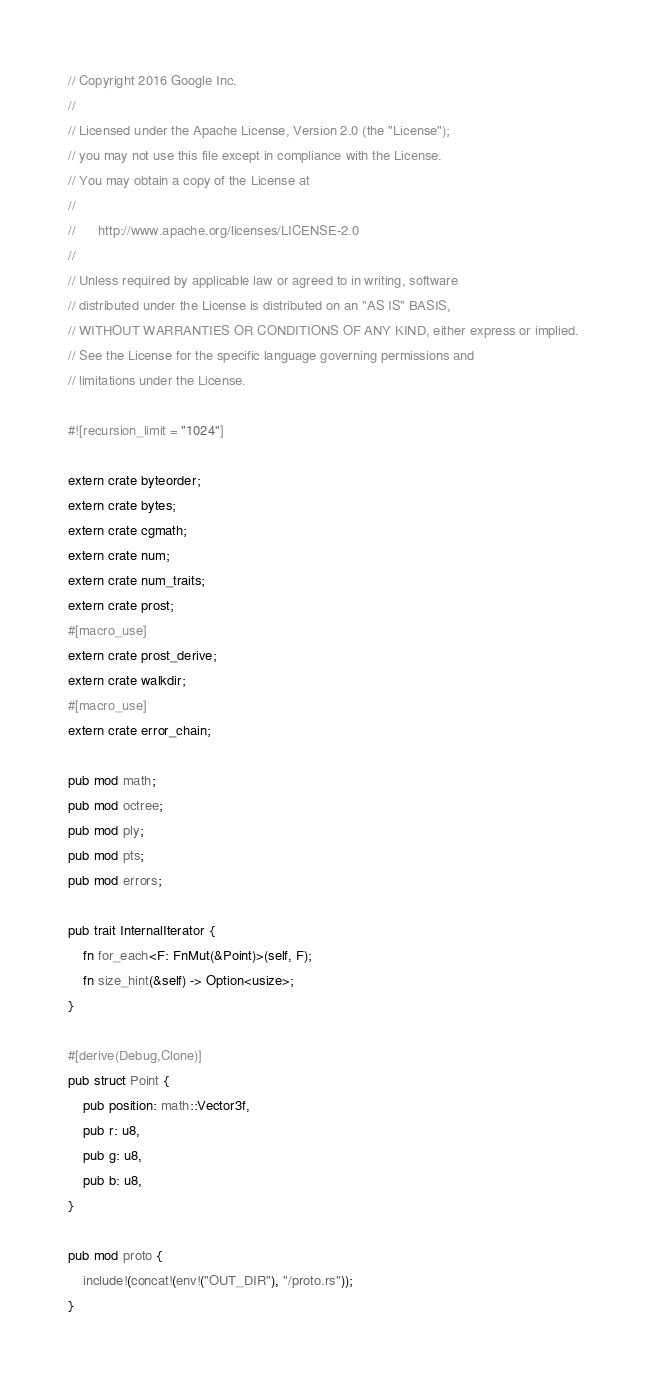<code> <loc_0><loc_0><loc_500><loc_500><_Rust_>// Copyright 2016 Google Inc.
//
// Licensed under the Apache License, Version 2.0 (the "License");
// you may not use this file except in compliance with the License.
// You may obtain a copy of the License at
//
//      http://www.apache.org/licenses/LICENSE-2.0
//
// Unless required by applicable law or agreed to in writing, software
// distributed under the License is distributed on an "AS IS" BASIS,
// WITHOUT WARRANTIES OR CONDITIONS OF ANY KIND, either express or implied.
// See the License for the specific language governing permissions and
// limitations under the License.

#![recursion_limit = "1024"]

extern crate byteorder;
extern crate bytes;
extern crate cgmath;
extern crate num;
extern crate num_traits;
extern crate prost;
#[macro_use]
extern crate prost_derive;
extern crate walkdir;
#[macro_use]
extern crate error_chain;

pub mod math;
pub mod octree;
pub mod ply;
pub mod pts;
pub mod errors;

pub trait InternalIterator {
    fn for_each<F: FnMut(&Point)>(self, F);
    fn size_hint(&self) -> Option<usize>;
}

#[derive(Debug,Clone)]
pub struct Point {
    pub position: math::Vector3f,
    pub r: u8,
    pub g: u8,
    pub b: u8,
}

pub mod proto {
    include!(concat!(env!("OUT_DIR"), "/proto.rs"));
}
</code> 